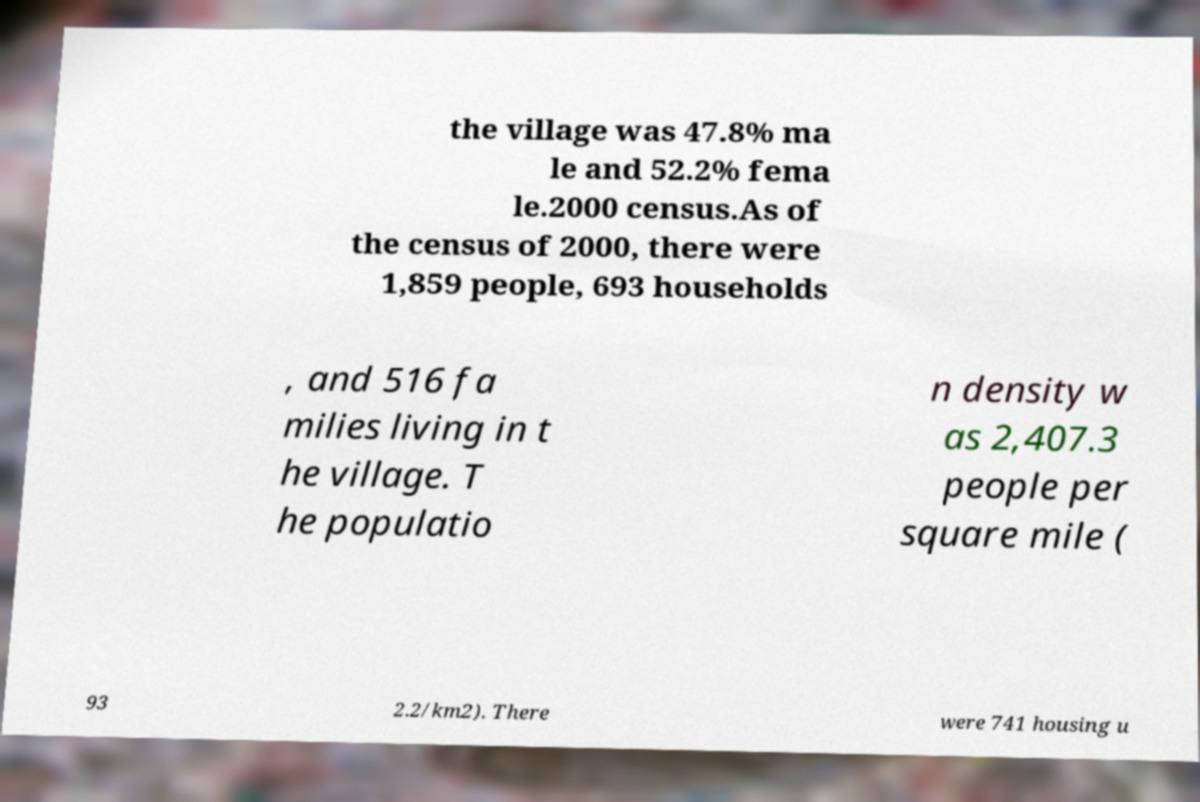Please read and relay the text visible in this image. What does it say? the village was 47.8% ma le and 52.2% fema le.2000 census.As of the census of 2000, there were 1,859 people, 693 households , and 516 fa milies living in t he village. T he populatio n density w as 2,407.3 people per square mile ( 93 2.2/km2). There were 741 housing u 